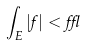<formula> <loc_0><loc_0><loc_500><loc_500>\int _ { E } | f | < \epsilon</formula> 